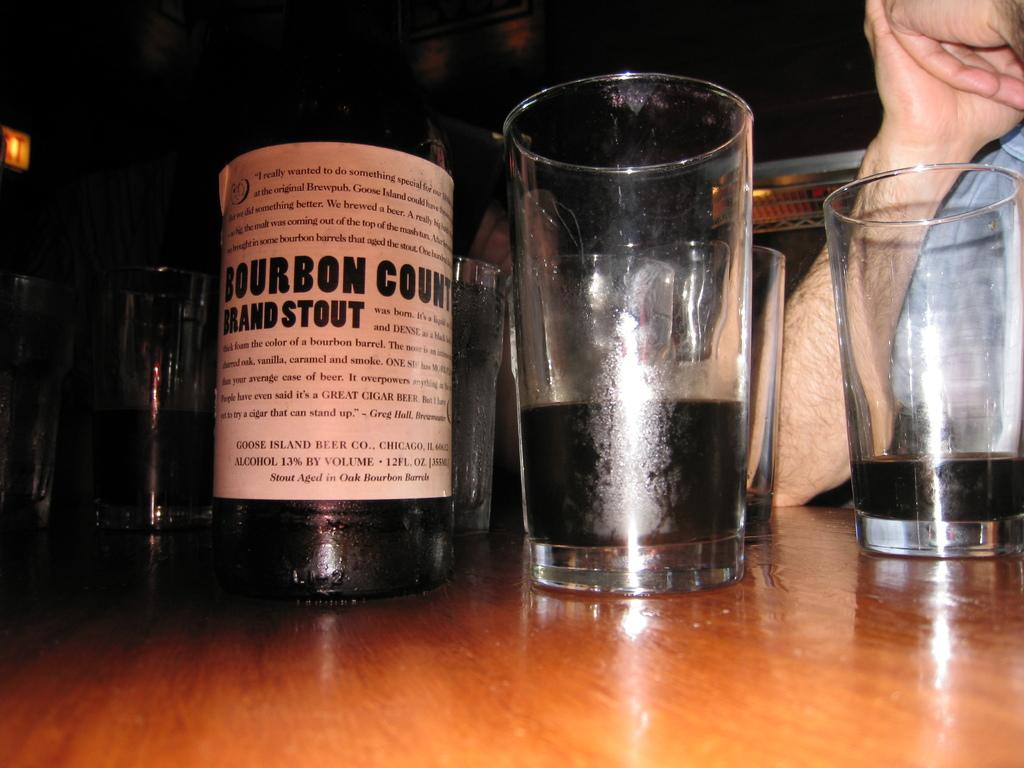<image>
Write a terse but informative summary of the picture. A bottle of Bourbon Brand Stout from Goose Island Beer Co. sits on a table next to half empty glasses. 